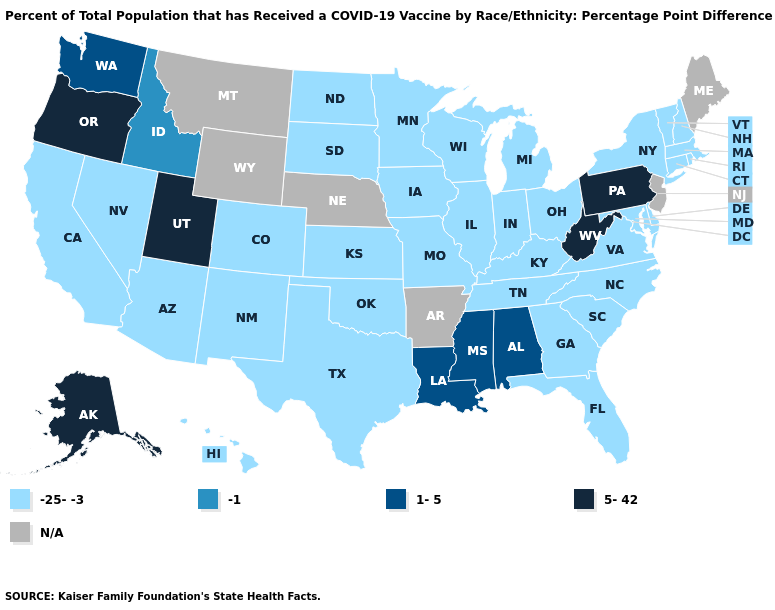Does the map have missing data?
Concise answer only. Yes. Name the states that have a value in the range -25--3?
Quick response, please. Arizona, California, Colorado, Connecticut, Delaware, Florida, Georgia, Hawaii, Illinois, Indiana, Iowa, Kansas, Kentucky, Maryland, Massachusetts, Michigan, Minnesota, Missouri, Nevada, New Hampshire, New Mexico, New York, North Carolina, North Dakota, Ohio, Oklahoma, Rhode Island, South Carolina, South Dakota, Tennessee, Texas, Vermont, Virginia, Wisconsin. How many symbols are there in the legend?
Write a very short answer. 5. Among the states that border Georgia , which have the lowest value?
Be succinct. Florida, North Carolina, South Carolina, Tennessee. What is the value of Indiana?
Concise answer only. -25--3. Among the states that border Washington , which have the lowest value?
Be succinct. Idaho. Does the first symbol in the legend represent the smallest category?
Give a very brief answer. Yes. Among the states that border Iowa , which have the highest value?
Be succinct. Illinois, Minnesota, Missouri, South Dakota, Wisconsin. What is the highest value in states that border New Jersey?
Keep it brief. 5-42. What is the lowest value in the South?
Be succinct. -25--3. Name the states that have a value in the range 5-42?
Be succinct. Alaska, Oregon, Pennsylvania, Utah, West Virginia. Is the legend a continuous bar?
Write a very short answer. No. Name the states that have a value in the range -25--3?
Concise answer only. Arizona, California, Colorado, Connecticut, Delaware, Florida, Georgia, Hawaii, Illinois, Indiana, Iowa, Kansas, Kentucky, Maryland, Massachusetts, Michigan, Minnesota, Missouri, Nevada, New Hampshire, New Mexico, New York, North Carolina, North Dakota, Ohio, Oklahoma, Rhode Island, South Carolina, South Dakota, Tennessee, Texas, Vermont, Virginia, Wisconsin. Name the states that have a value in the range N/A?
Give a very brief answer. Arkansas, Maine, Montana, Nebraska, New Jersey, Wyoming. Among the states that border Mississippi , does Louisiana have the lowest value?
Answer briefly. No. 